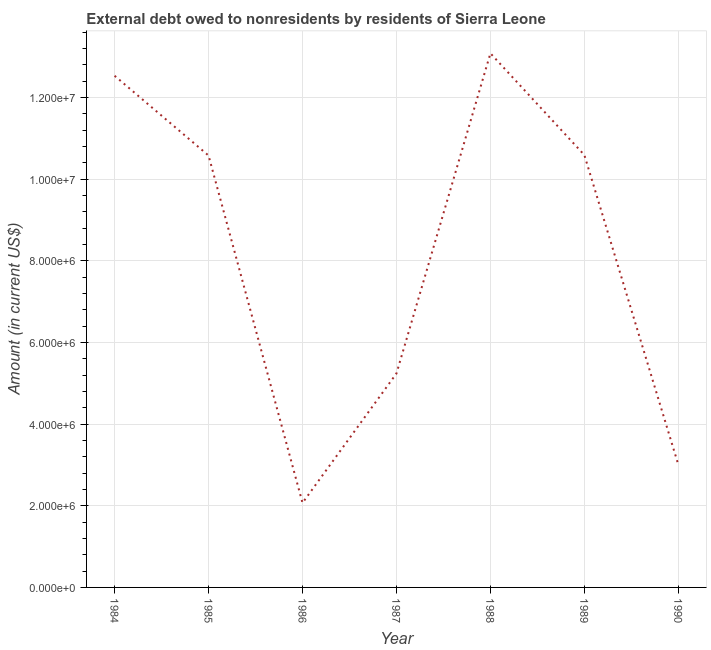What is the debt in 1985?
Ensure brevity in your answer.  1.06e+07. Across all years, what is the maximum debt?
Your answer should be compact. 1.31e+07. Across all years, what is the minimum debt?
Give a very brief answer. 2.07e+06. In which year was the debt maximum?
Your response must be concise. 1988. What is the sum of the debt?
Offer a very short reply. 5.71e+07. What is the difference between the debt in 1985 and 1990?
Provide a short and direct response. 7.57e+06. What is the average debt per year?
Offer a very short reply. 8.16e+06. What is the median debt?
Ensure brevity in your answer.  1.06e+07. Do a majority of the years between 1986 and 1987 (inclusive) have debt greater than 8800000 US$?
Your response must be concise. No. What is the ratio of the debt in 1985 to that in 1987?
Provide a succinct answer. 2.02. Is the debt in 1985 less than that in 1990?
Provide a succinct answer. No. Is the difference between the debt in 1987 and 1989 greater than the difference between any two years?
Ensure brevity in your answer.  No. What is the difference between the highest and the second highest debt?
Keep it short and to the point. 5.51e+05. Is the sum of the debt in 1985 and 1988 greater than the maximum debt across all years?
Offer a terse response. Yes. What is the difference between the highest and the lowest debt?
Provide a succinct answer. 1.10e+07. In how many years, is the debt greater than the average debt taken over all years?
Your answer should be compact. 4. How many years are there in the graph?
Make the answer very short. 7. Are the values on the major ticks of Y-axis written in scientific E-notation?
Ensure brevity in your answer.  Yes. Does the graph contain grids?
Provide a short and direct response. Yes. What is the title of the graph?
Your answer should be very brief. External debt owed to nonresidents by residents of Sierra Leone. What is the label or title of the X-axis?
Provide a short and direct response. Year. What is the label or title of the Y-axis?
Give a very brief answer. Amount (in current US$). What is the Amount (in current US$) in 1984?
Keep it short and to the point. 1.25e+07. What is the Amount (in current US$) in 1985?
Make the answer very short. 1.06e+07. What is the Amount (in current US$) in 1986?
Provide a succinct answer. 2.07e+06. What is the Amount (in current US$) of 1987?
Offer a terse response. 5.24e+06. What is the Amount (in current US$) of 1988?
Your response must be concise. 1.31e+07. What is the Amount (in current US$) of 1989?
Ensure brevity in your answer.  1.06e+07. What is the Amount (in current US$) in 1990?
Offer a very short reply. 3.01e+06. What is the difference between the Amount (in current US$) in 1984 and 1985?
Your answer should be very brief. 1.95e+06. What is the difference between the Amount (in current US$) in 1984 and 1986?
Provide a succinct answer. 1.05e+07. What is the difference between the Amount (in current US$) in 1984 and 1987?
Ensure brevity in your answer.  7.29e+06. What is the difference between the Amount (in current US$) in 1984 and 1988?
Offer a terse response. -5.51e+05. What is the difference between the Amount (in current US$) in 1984 and 1989?
Make the answer very short. 1.94e+06. What is the difference between the Amount (in current US$) in 1984 and 1990?
Ensure brevity in your answer.  9.53e+06. What is the difference between the Amount (in current US$) in 1985 and 1986?
Give a very brief answer. 8.51e+06. What is the difference between the Amount (in current US$) in 1985 and 1987?
Give a very brief answer. 5.34e+06. What is the difference between the Amount (in current US$) in 1985 and 1988?
Keep it short and to the point. -2.50e+06. What is the difference between the Amount (in current US$) in 1985 and 1989?
Keep it short and to the point. -1.30e+04. What is the difference between the Amount (in current US$) in 1985 and 1990?
Your answer should be compact. 7.57e+06. What is the difference between the Amount (in current US$) in 1986 and 1987?
Your answer should be compact. -3.17e+06. What is the difference between the Amount (in current US$) in 1986 and 1988?
Offer a very short reply. -1.10e+07. What is the difference between the Amount (in current US$) in 1986 and 1989?
Offer a very short reply. -8.52e+06. What is the difference between the Amount (in current US$) in 1986 and 1990?
Make the answer very short. -9.36e+05. What is the difference between the Amount (in current US$) in 1987 and 1988?
Your answer should be very brief. -7.84e+06. What is the difference between the Amount (in current US$) in 1987 and 1989?
Make the answer very short. -5.35e+06. What is the difference between the Amount (in current US$) in 1987 and 1990?
Offer a very short reply. 2.23e+06. What is the difference between the Amount (in current US$) in 1988 and 1989?
Offer a very short reply. 2.49e+06. What is the difference between the Amount (in current US$) in 1988 and 1990?
Offer a terse response. 1.01e+07. What is the difference between the Amount (in current US$) in 1989 and 1990?
Your response must be concise. 7.58e+06. What is the ratio of the Amount (in current US$) in 1984 to that in 1985?
Your answer should be very brief. 1.19. What is the ratio of the Amount (in current US$) in 1984 to that in 1986?
Your answer should be compact. 6.05. What is the ratio of the Amount (in current US$) in 1984 to that in 1987?
Provide a succinct answer. 2.39. What is the ratio of the Amount (in current US$) in 1984 to that in 1988?
Your answer should be compact. 0.96. What is the ratio of the Amount (in current US$) in 1984 to that in 1989?
Offer a very short reply. 1.18. What is the ratio of the Amount (in current US$) in 1984 to that in 1990?
Ensure brevity in your answer.  4.17. What is the ratio of the Amount (in current US$) in 1985 to that in 1986?
Ensure brevity in your answer.  5.11. What is the ratio of the Amount (in current US$) in 1985 to that in 1987?
Provide a short and direct response. 2.02. What is the ratio of the Amount (in current US$) in 1985 to that in 1988?
Your response must be concise. 0.81. What is the ratio of the Amount (in current US$) in 1985 to that in 1990?
Make the answer very short. 3.52. What is the ratio of the Amount (in current US$) in 1986 to that in 1987?
Provide a short and direct response. 0.4. What is the ratio of the Amount (in current US$) in 1986 to that in 1988?
Make the answer very short. 0.16. What is the ratio of the Amount (in current US$) in 1986 to that in 1989?
Offer a terse response. 0.2. What is the ratio of the Amount (in current US$) in 1986 to that in 1990?
Your answer should be compact. 0.69. What is the ratio of the Amount (in current US$) in 1987 to that in 1988?
Give a very brief answer. 0.4. What is the ratio of the Amount (in current US$) in 1987 to that in 1989?
Your answer should be compact. 0.49. What is the ratio of the Amount (in current US$) in 1987 to that in 1990?
Give a very brief answer. 1.74. What is the ratio of the Amount (in current US$) in 1988 to that in 1989?
Provide a succinct answer. 1.24. What is the ratio of the Amount (in current US$) in 1988 to that in 1990?
Keep it short and to the point. 4.35. What is the ratio of the Amount (in current US$) in 1989 to that in 1990?
Provide a short and direct response. 3.52. 